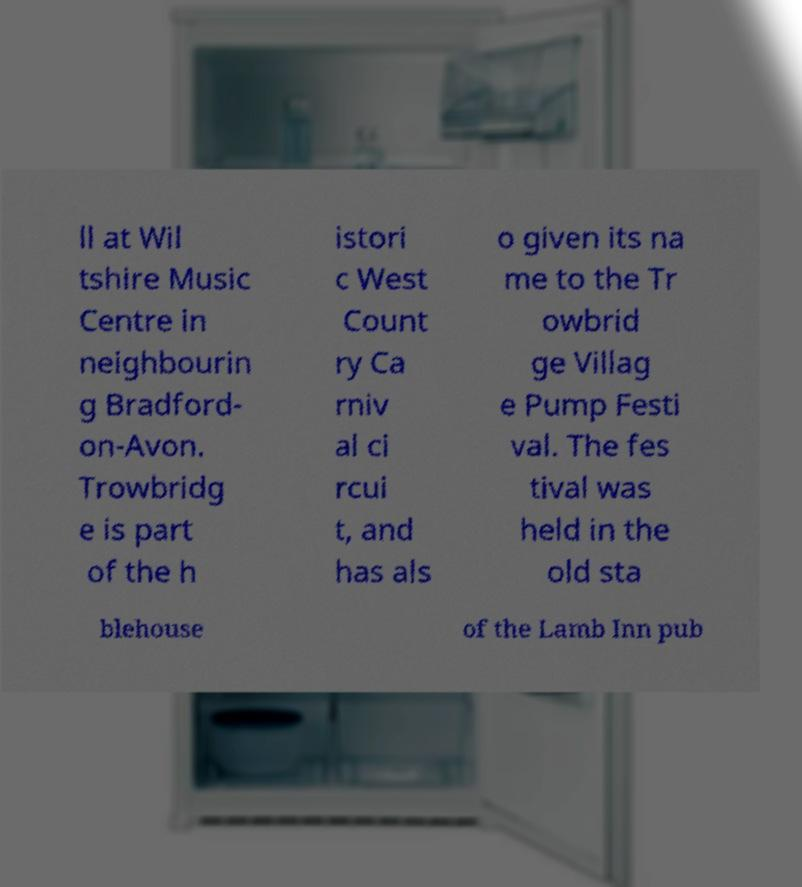Could you extract and type out the text from this image? ll at Wil tshire Music Centre in neighbourin g Bradford- on-Avon. Trowbridg e is part of the h istori c West Count ry Ca rniv al ci rcui t, and has als o given its na me to the Tr owbrid ge Villag e Pump Festi val. The fes tival was held in the old sta blehouse of the Lamb Inn pub 